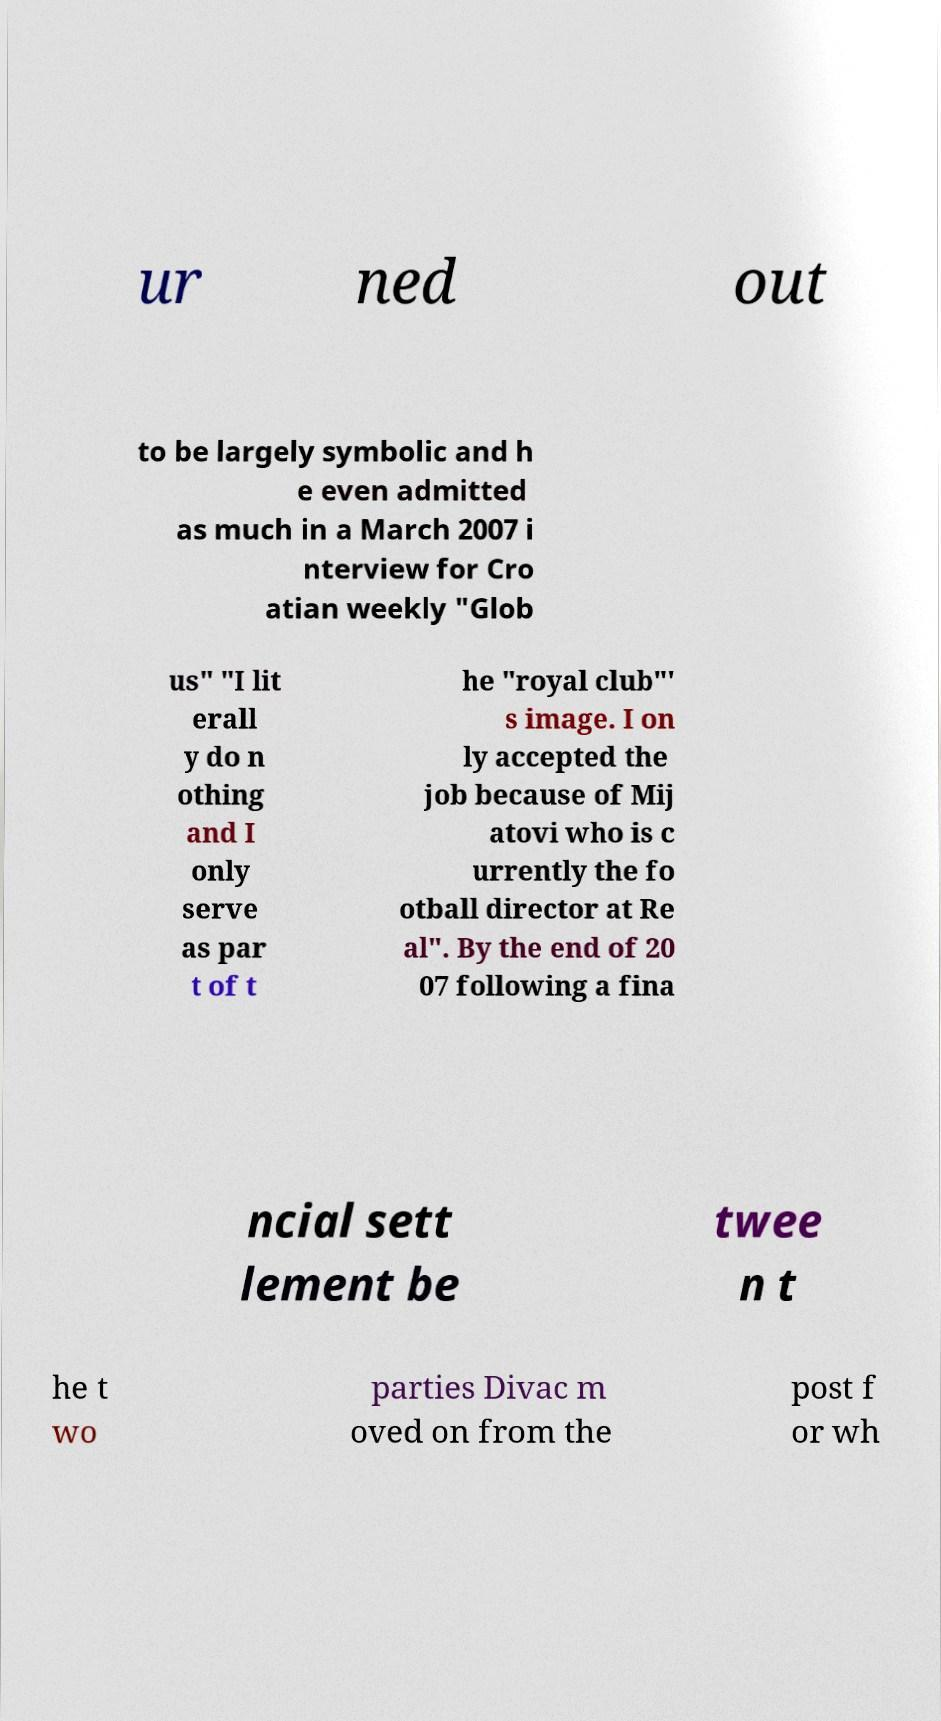What messages or text are displayed in this image? I need them in a readable, typed format. ur ned out to be largely symbolic and h e even admitted as much in a March 2007 i nterview for Cro atian weekly "Glob us" "I lit erall y do n othing and I only serve as par t of t he "royal club"' s image. I on ly accepted the job because of Mij atovi who is c urrently the fo otball director at Re al". By the end of 20 07 following a fina ncial sett lement be twee n t he t wo parties Divac m oved on from the post f or wh 